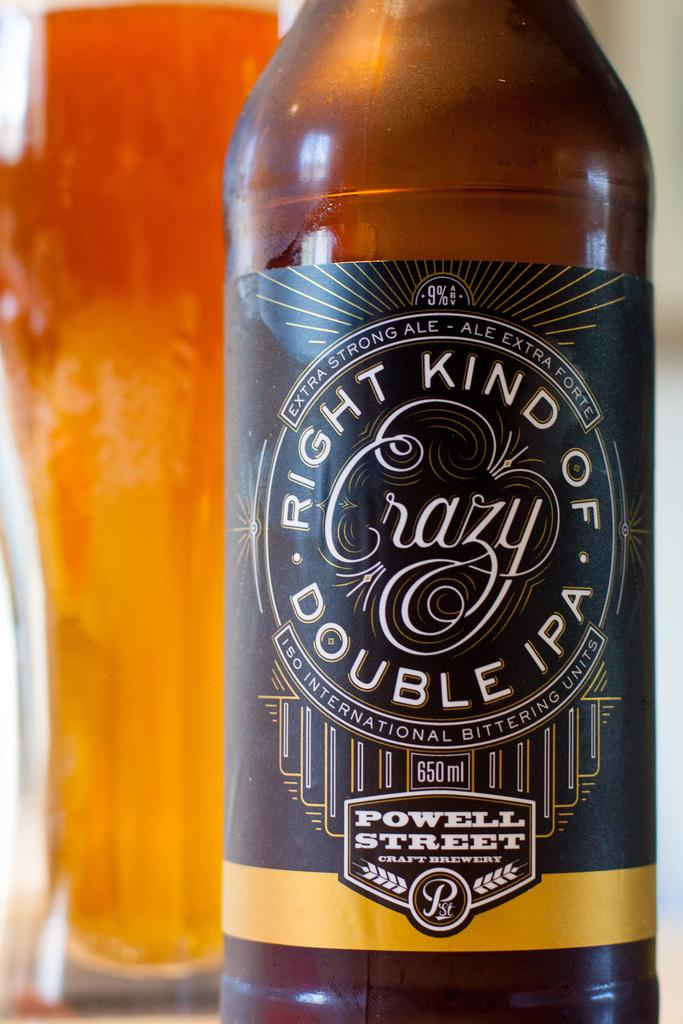<image>
Render a clear and concise summary of the photo. A bottle with a Powell Street  brewery label is in front of a filled glass. 